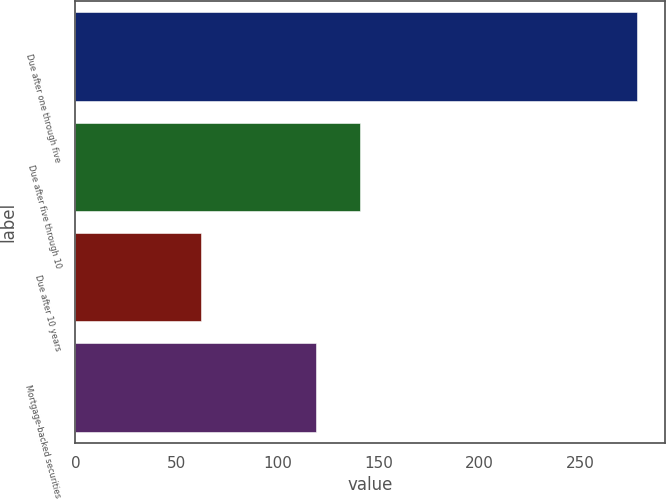<chart> <loc_0><loc_0><loc_500><loc_500><bar_chart><fcel>Due after one through five<fcel>Due after five through 10<fcel>Due after 10 years<fcel>Mortgage-backed securities<nl><fcel>278<fcel>140.6<fcel>62<fcel>119<nl></chart> 